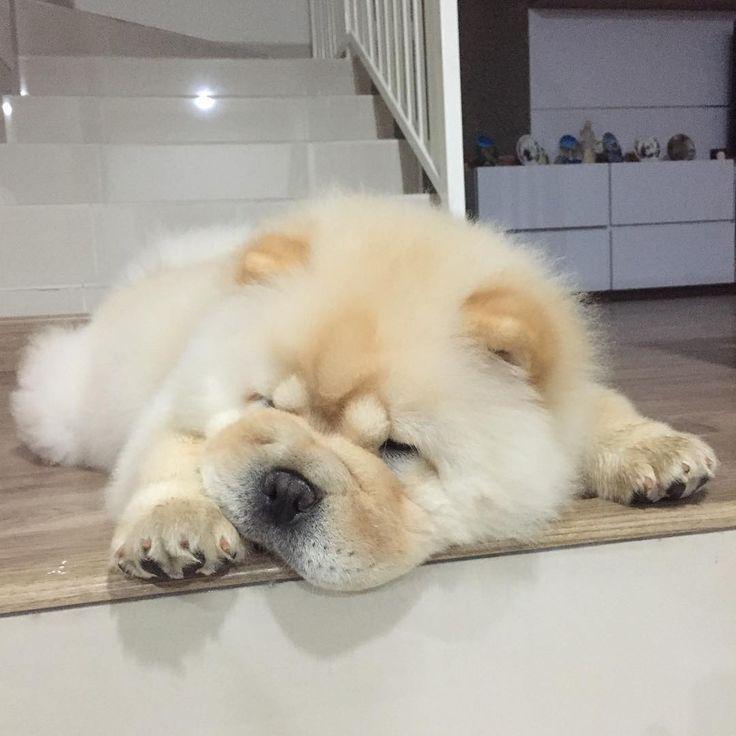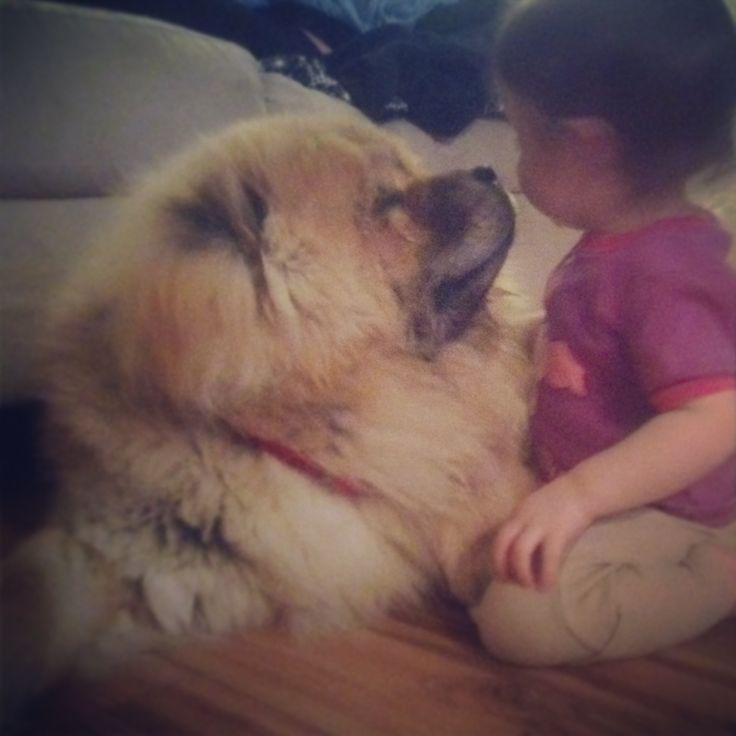The first image is the image on the left, the second image is the image on the right. Assess this claim about the two images: "The left and right image contains the same number of dog and on the right image there is a child.". Correct or not? Answer yes or no. Yes. The first image is the image on the left, the second image is the image on the right. For the images shown, is this caption "The right image shows a baby sitting to the right of an adult chow, and the left image shows one forward-turned cream-colored chow puppy." true? Answer yes or no. Yes. 